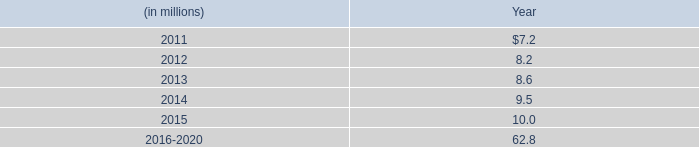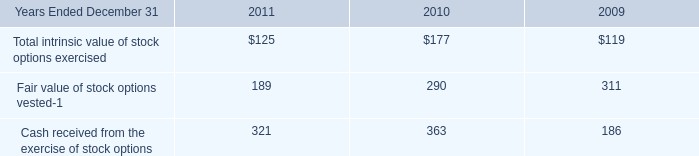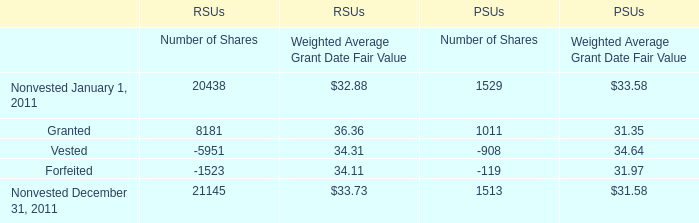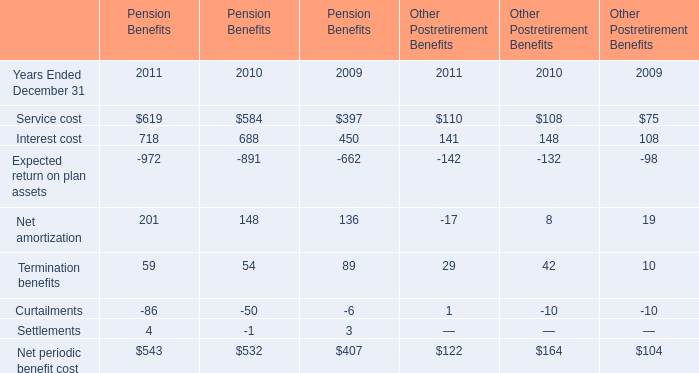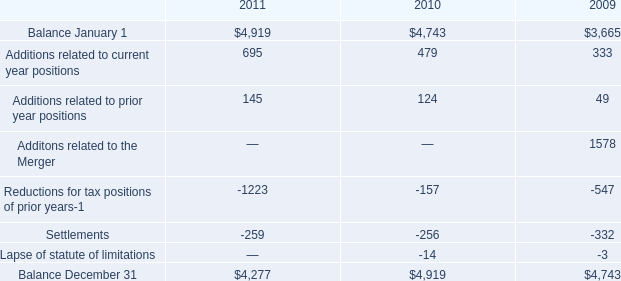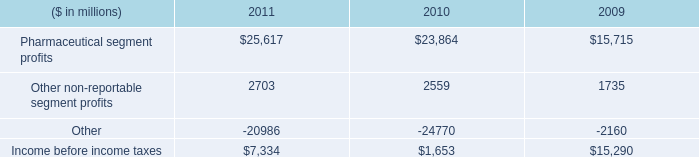Which element for Pension Benefits makes up more than 80 % of the total in 2011? 
Answer: Service cost, Interest cost. 